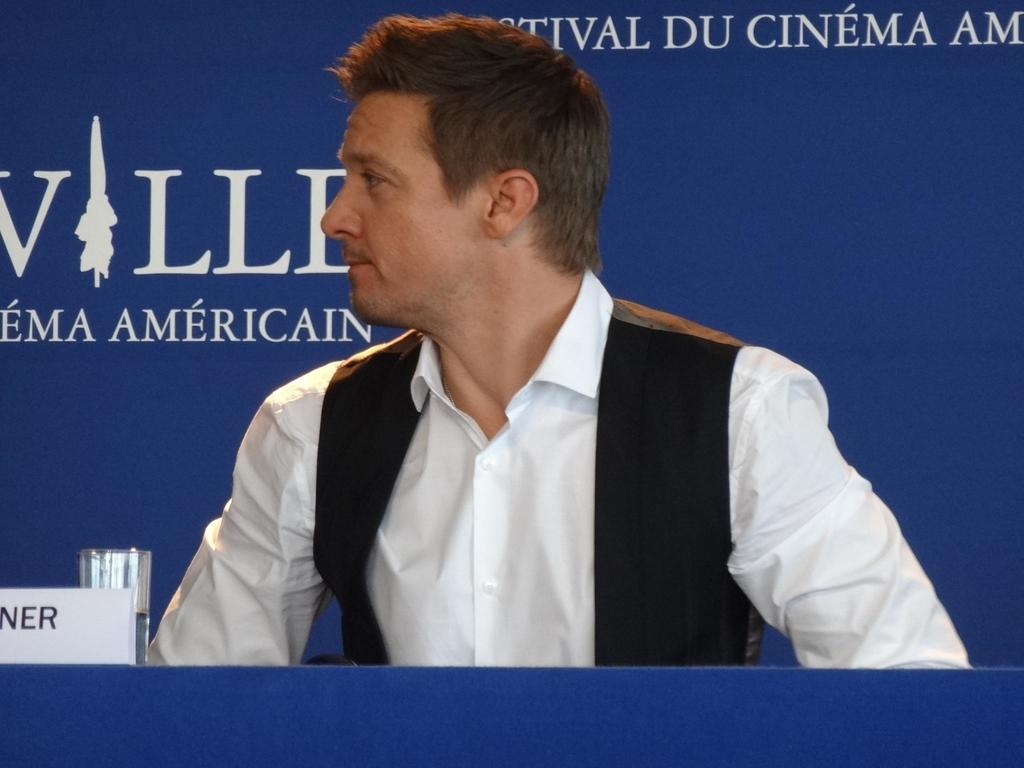Who is present in the image? There is a man in the image. What is in front of the man? There is a glass in front of the man. What object can be seen on a table in the image? There is a name board on a table in the image. What can be seen in the background of the image? There is a hoarding in the background of the image. What color is the box that the man is holding in the image? There is no box present in the image, so it is not possible to determine its color. 